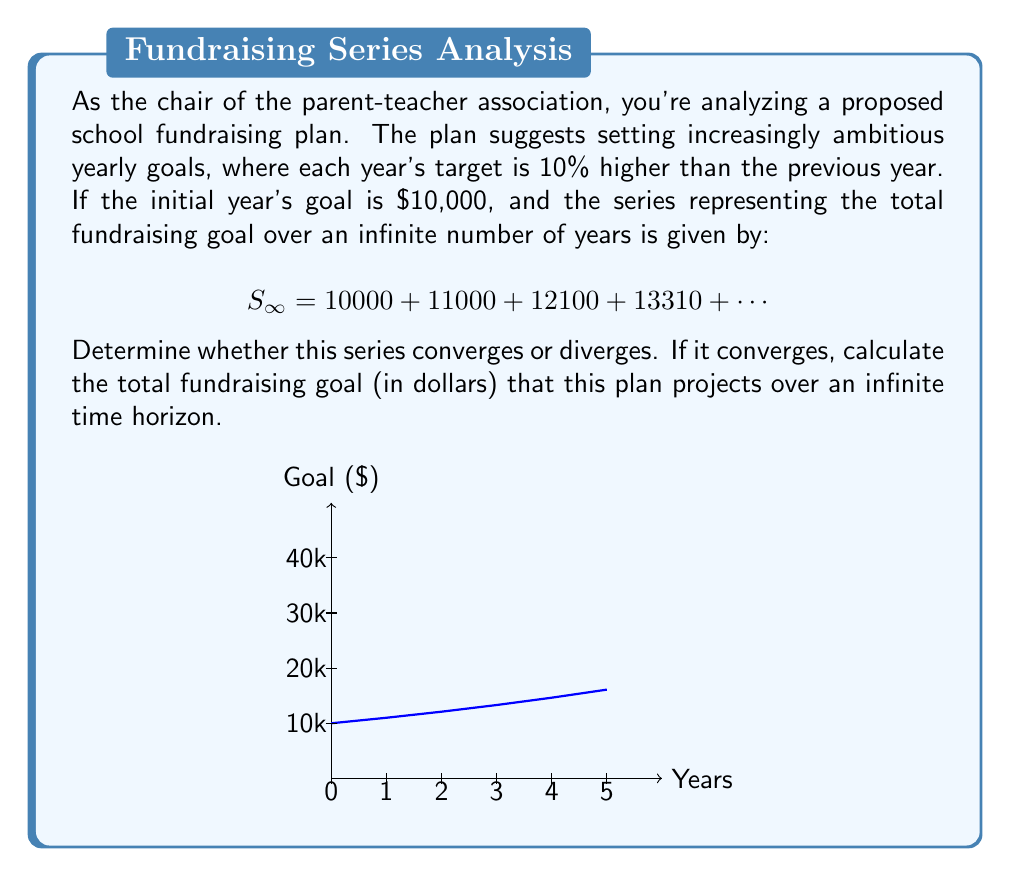Provide a solution to this math problem. Let's approach this step-by-step:

1) First, we need to recognize the pattern in this series. Each term is 1.1 times the previous term, starting with 10000.

2) This is a geometric series with first term $a = 10000$ and common ratio $r = 1.1$.

3) The general formula for the nth term of this series is:
   $$a_n = 10000 \cdot (1.1)^{n-1}$$

4) For a geometric series, we know that:
   - If $|r| < 1$, the series converges
   - If $|r| \geq 1$, the series diverges

5) In this case, $r = 1.1$, which is greater than 1.

6) Therefore, this series diverges.

7) However, as a lawyer and PTA member, you might be interested in what this means practically. It suggests that if this fundraising plan were to continue indefinitely, the total amount raised would grow without bound.

8) While the series diverges over an infinite time horizon, we could calculate the sum for any finite number of years using the formula for the sum of a geometric series:
   $$S_n = \frac{a(1-r^n)}{1-r}$$
   where $n$ is the number of years.
Answer: The series diverges. 